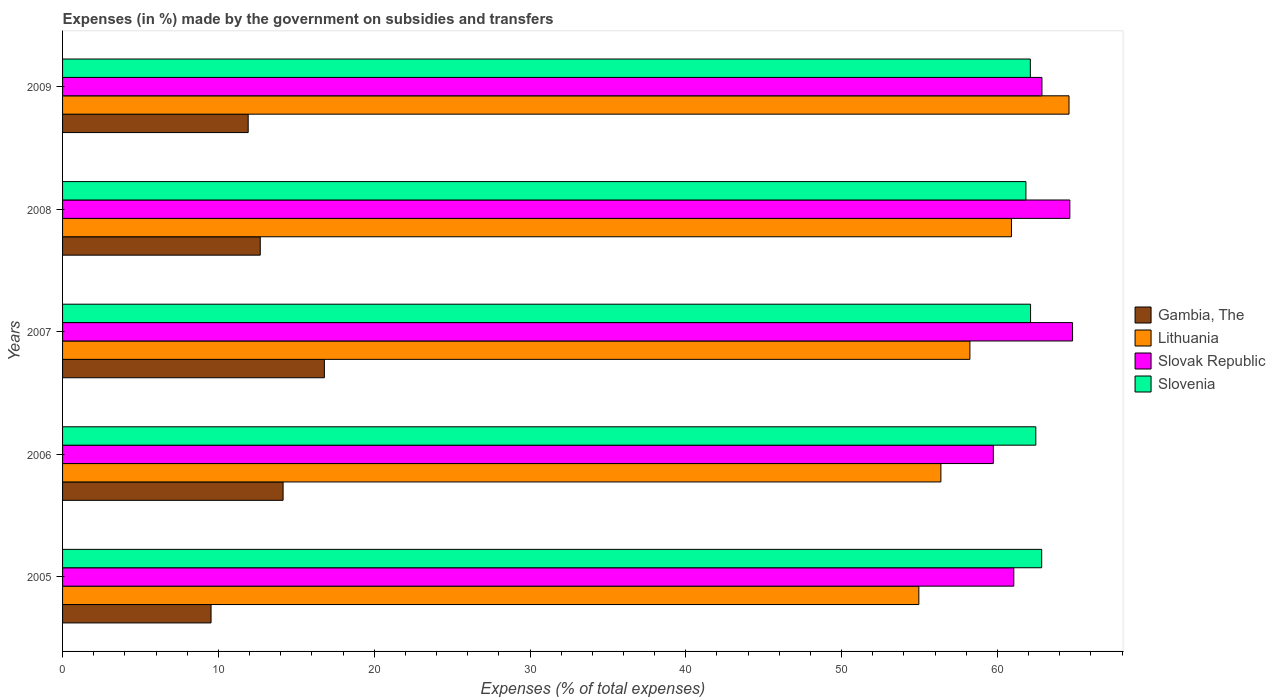How many different coloured bars are there?
Keep it short and to the point. 4. How many groups of bars are there?
Provide a short and direct response. 5. Are the number of bars per tick equal to the number of legend labels?
Offer a terse response. Yes. How many bars are there on the 2nd tick from the top?
Your answer should be compact. 4. What is the label of the 3rd group of bars from the top?
Provide a succinct answer. 2007. What is the percentage of expenses made by the government on subsidies and transfers in Gambia, The in 2009?
Give a very brief answer. 11.91. Across all years, what is the maximum percentage of expenses made by the government on subsidies and transfers in Slovenia?
Your answer should be very brief. 62.84. Across all years, what is the minimum percentage of expenses made by the government on subsidies and transfers in Lithuania?
Your answer should be compact. 54.96. In which year was the percentage of expenses made by the government on subsidies and transfers in Gambia, The maximum?
Keep it short and to the point. 2007. In which year was the percentage of expenses made by the government on subsidies and transfers in Slovak Republic minimum?
Provide a succinct answer. 2006. What is the total percentage of expenses made by the government on subsidies and transfers in Slovenia in the graph?
Keep it short and to the point. 311.37. What is the difference between the percentage of expenses made by the government on subsidies and transfers in Gambia, The in 2007 and that in 2009?
Ensure brevity in your answer.  4.89. What is the difference between the percentage of expenses made by the government on subsidies and transfers in Slovak Republic in 2005 and the percentage of expenses made by the government on subsidies and transfers in Lithuania in 2009?
Keep it short and to the point. -3.54. What is the average percentage of expenses made by the government on subsidies and transfers in Slovak Republic per year?
Keep it short and to the point. 62.62. In the year 2008, what is the difference between the percentage of expenses made by the government on subsidies and transfers in Gambia, The and percentage of expenses made by the government on subsidies and transfers in Slovak Republic?
Offer a terse response. -51.96. In how many years, is the percentage of expenses made by the government on subsidies and transfers in Gambia, The greater than 26 %?
Your response must be concise. 0. What is the ratio of the percentage of expenses made by the government on subsidies and transfers in Lithuania in 2005 to that in 2007?
Provide a short and direct response. 0.94. Is the percentage of expenses made by the government on subsidies and transfers in Slovak Republic in 2007 less than that in 2008?
Provide a succinct answer. No. Is the difference between the percentage of expenses made by the government on subsidies and transfers in Gambia, The in 2005 and 2007 greater than the difference between the percentage of expenses made by the government on subsidies and transfers in Slovak Republic in 2005 and 2007?
Offer a terse response. No. What is the difference between the highest and the second highest percentage of expenses made by the government on subsidies and transfers in Slovenia?
Offer a terse response. 0.38. What is the difference between the highest and the lowest percentage of expenses made by the government on subsidies and transfers in Lithuania?
Make the answer very short. 9.64. What does the 3rd bar from the top in 2007 represents?
Provide a succinct answer. Lithuania. What does the 1st bar from the bottom in 2005 represents?
Ensure brevity in your answer.  Gambia, The. Are all the bars in the graph horizontal?
Provide a succinct answer. Yes. How many years are there in the graph?
Ensure brevity in your answer.  5. Are the values on the major ticks of X-axis written in scientific E-notation?
Your response must be concise. No. Does the graph contain grids?
Give a very brief answer. No. How many legend labels are there?
Make the answer very short. 4. What is the title of the graph?
Ensure brevity in your answer.  Expenses (in %) made by the government on subsidies and transfers. What is the label or title of the X-axis?
Your answer should be very brief. Expenses (% of total expenses). What is the Expenses (% of total expenses) of Gambia, The in 2005?
Your answer should be compact. 9.53. What is the Expenses (% of total expenses) in Lithuania in 2005?
Give a very brief answer. 54.96. What is the Expenses (% of total expenses) of Slovak Republic in 2005?
Your answer should be very brief. 61.05. What is the Expenses (% of total expenses) in Slovenia in 2005?
Your answer should be compact. 62.84. What is the Expenses (% of total expenses) in Gambia, The in 2006?
Offer a very short reply. 14.15. What is the Expenses (% of total expenses) in Lithuania in 2006?
Offer a terse response. 56.37. What is the Expenses (% of total expenses) in Slovak Republic in 2006?
Ensure brevity in your answer.  59.74. What is the Expenses (% of total expenses) in Slovenia in 2006?
Make the answer very short. 62.46. What is the Expenses (% of total expenses) in Gambia, The in 2007?
Offer a terse response. 16.8. What is the Expenses (% of total expenses) in Lithuania in 2007?
Your answer should be very brief. 58.23. What is the Expenses (% of total expenses) of Slovak Republic in 2007?
Your answer should be compact. 64.82. What is the Expenses (% of total expenses) of Slovenia in 2007?
Provide a succinct answer. 62.13. What is the Expenses (% of total expenses) of Gambia, The in 2008?
Your answer should be very brief. 12.69. What is the Expenses (% of total expenses) of Lithuania in 2008?
Ensure brevity in your answer.  60.9. What is the Expenses (% of total expenses) of Slovak Republic in 2008?
Offer a terse response. 64.65. What is the Expenses (% of total expenses) in Slovenia in 2008?
Your answer should be compact. 61.83. What is the Expenses (% of total expenses) in Gambia, The in 2009?
Keep it short and to the point. 11.91. What is the Expenses (% of total expenses) of Lithuania in 2009?
Your answer should be compact. 64.59. What is the Expenses (% of total expenses) in Slovak Republic in 2009?
Offer a terse response. 62.86. What is the Expenses (% of total expenses) of Slovenia in 2009?
Provide a succinct answer. 62.11. Across all years, what is the maximum Expenses (% of total expenses) of Gambia, The?
Your answer should be very brief. 16.8. Across all years, what is the maximum Expenses (% of total expenses) of Lithuania?
Offer a terse response. 64.59. Across all years, what is the maximum Expenses (% of total expenses) of Slovak Republic?
Give a very brief answer. 64.82. Across all years, what is the maximum Expenses (% of total expenses) of Slovenia?
Give a very brief answer. 62.84. Across all years, what is the minimum Expenses (% of total expenses) in Gambia, The?
Give a very brief answer. 9.53. Across all years, what is the minimum Expenses (% of total expenses) in Lithuania?
Provide a succinct answer. 54.96. Across all years, what is the minimum Expenses (% of total expenses) of Slovak Republic?
Offer a very short reply. 59.74. Across all years, what is the minimum Expenses (% of total expenses) in Slovenia?
Offer a terse response. 61.83. What is the total Expenses (% of total expenses) in Gambia, The in the graph?
Your answer should be compact. 65.09. What is the total Expenses (% of total expenses) in Lithuania in the graph?
Your response must be concise. 295.05. What is the total Expenses (% of total expenses) in Slovak Republic in the graph?
Provide a succinct answer. 313.11. What is the total Expenses (% of total expenses) in Slovenia in the graph?
Provide a succinct answer. 311.37. What is the difference between the Expenses (% of total expenses) of Gambia, The in 2005 and that in 2006?
Your answer should be compact. -4.62. What is the difference between the Expenses (% of total expenses) of Lithuania in 2005 and that in 2006?
Keep it short and to the point. -1.42. What is the difference between the Expenses (% of total expenses) of Slovak Republic in 2005 and that in 2006?
Ensure brevity in your answer.  1.31. What is the difference between the Expenses (% of total expenses) in Slovenia in 2005 and that in 2006?
Your response must be concise. 0.38. What is the difference between the Expenses (% of total expenses) of Gambia, The in 2005 and that in 2007?
Your answer should be very brief. -7.27. What is the difference between the Expenses (% of total expenses) of Lithuania in 2005 and that in 2007?
Offer a terse response. -3.28. What is the difference between the Expenses (% of total expenses) in Slovak Republic in 2005 and that in 2007?
Provide a succinct answer. -3.77. What is the difference between the Expenses (% of total expenses) of Slovenia in 2005 and that in 2007?
Provide a short and direct response. 0.71. What is the difference between the Expenses (% of total expenses) in Gambia, The in 2005 and that in 2008?
Your response must be concise. -3.16. What is the difference between the Expenses (% of total expenses) of Lithuania in 2005 and that in 2008?
Provide a short and direct response. -5.94. What is the difference between the Expenses (% of total expenses) in Slovak Republic in 2005 and that in 2008?
Give a very brief answer. -3.6. What is the difference between the Expenses (% of total expenses) in Slovenia in 2005 and that in 2008?
Offer a very short reply. 1.01. What is the difference between the Expenses (% of total expenses) of Gambia, The in 2005 and that in 2009?
Your answer should be very brief. -2.38. What is the difference between the Expenses (% of total expenses) in Lithuania in 2005 and that in 2009?
Offer a terse response. -9.64. What is the difference between the Expenses (% of total expenses) of Slovak Republic in 2005 and that in 2009?
Provide a succinct answer. -1.81. What is the difference between the Expenses (% of total expenses) in Slovenia in 2005 and that in 2009?
Your answer should be compact. 0.73. What is the difference between the Expenses (% of total expenses) of Gambia, The in 2006 and that in 2007?
Offer a very short reply. -2.65. What is the difference between the Expenses (% of total expenses) of Lithuania in 2006 and that in 2007?
Offer a very short reply. -1.86. What is the difference between the Expenses (% of total expenses) in Slovak Republic in 2006 and that in 2007?
Provide a short and direct response. -5.09. What is the difference between the Expenses (% of total expenses) in Slovenia in 2006 and that in 2007?
Offer a very short reply. 0.34. What is the difference between the Expenses (% of total expenses) of Gambia, The in 2006 and that in 2008?
Provide a succinct answer. 1.47. What is the difference between the Expenses (% of total expenses) of Lithuania in 2006 and that in 2008?
Provide a succinct answer. -4.53. What is the difference between the Expenses (% of total expenses) in Slovak Republic in 2006 and that in 2008?
Your response must be concise. -4.91. What is the difference between the Expenses (% of total expenses) in Slovenia in 2006 and that in 2008?
Give a very brief answer. 0.63. What is the difference between the Expenses (% of total expenses) in Gambia, The in 2006 and that in 2009?
Make the answer very short. 2.24. What is the difference between the Expenses (% of total expenses) of Lithuania in 2006 and that in 2009?
Offer a very short reply. -8.22. What is the difference between the Expenses (% of total expenses) of Slovak Republic in 2006 and that in 2009?
Offer a terse response. -3.12. What is the difference between the Expenses (% of total expenses) in Slovenia in 2006 and that in 2009?
Offer a terse response. 0.35. What is the difference between the Expenses (% of total expenses) in Gambia, The in 2007 and that in 2008?
Keep it short and to the point. 4.11. What is the difference between the Expenses (% of total expenses) in Lithuania in 2007 and that in 2008?
Provide a short and direct response. -2.67. What is the difference between the Expenses (% of total expenses) of Slovak Republic in 2007 and that in 2008?
Offer a terse response. 0.17. What is the difference between the Expenses (% of total expenses) in Slovenia in 2007 and that in 2008?
Your answer should be very brief. 0.3. What is the difference between the Expenses (% of total expenses) in Gambia, The in 2007 and that in 2009?
Offer a terse response. 4.89. What is the difference between the Expenses (% of total expenses) in Lithuania in 2007 and that in 2009?
Provide a short and direct response. -6.36. What is the difference between the Expenses (% of total expenses) in Slovak Republic in 2007 and that in 2009?
Your answer should be compact. 1.96. What is the difference between the Expenses (% of total expenses) in Slovenia in 2007 and that in 2009?
Your answer should be compact. 0.01. What is the difference between the Expenses (% of total expenses) in Gambia, The in 2008 and that in 2009?
Provide a succinct answer. 0.77. What is the difference between the Expenses (% of total expenses) of Lithuania in 2008 and that in 2009?
Keep it short and to the point. -3.69. What is the difference between the Expenses (% of total expenses) in Slovak Republic in 2008 and that in 2009?
Your response must be concise. 1.79. What is the difference between the Expenses (% of total expenses) in Slovenia in 2008 and that in 2009?
Offer a terse response. -0.28. What is the difference between the Expenses (% of total expenses) in Gambia, The in 2005 and the Expenses (% of total expenses) in Lithuania in 2006?
Provide a short and direct response. -46.84. What is the difference between the Expenses (% of total expenses) of Gambia, The in 2005 and the Expenses (% of total expenses) of Slovak Republic in 2006?
Your response must be concise. -50.21. What is the difference between the Expenses (% of total expenses) in Gambia, The in 2005 and the Expenses (% of total expenses) in Slovenia in 2006?
Make the answer very short. -52.93. What is the difference between the Expenses (% of total expenses) in Lithuania in 2005 and the Expenses (% of total expenses) in Slovak Republic in 2006?
Keep it short and to the point. -4.78. What is the difference between the Expenses (% of total expenses) of Lithuania in 2005 and the Expenses (% of total expenses) of Slovenia in 2006?
Your answer should be compact. -7.51. What is the difference between the Expenses (% of total expenses) of Slovak Republic in 2005 and the Expenses (% of total expenses) of Slovenia in 2006?
Your answer should be very brief. -1.41. What is the difference between the Expenses (% of total expenses) of Gambia, The in 2005 and the Expenses (% of total expenses) of Lithuania in 2007?
Give a very brief answer. -48.7. What is the difference between the Expenses (% of total expenses) of Gambia, The in 2005 and the Expenses (% of total expenses) of Slovak Republic in 2007?
Offer a very short reply. -55.29. What is the difference between the Expenses (% of total expenses) of Gambia, The in 2005 and the Expenses (% of total expenses) of Slovenia in 2007?
Make the answer very short. -52.6. What is the difference between the Expenses (% of total expenses) in Lithuania in 2005 and the Expenses (% of total expenses) in Slovak Republic in 2007?
Provide a short and direct response. -9.87. What is the difference between the Expenses (% of total expenses) of Lithuania in 2005 and the Expenses (% of total expenses) of Slovenia in 2007?
Your answer should be very brief. -7.17. What is the difference between the Expenses (% of total expenses) in Slovak Republic in 2005 and the Expenses (% of total expenses) in Slovenia in 2007?
Give a very brief answer. -1.08. What is the difference between the Expenses (% of total expenses) in Gambia, The in 2005 and the Expenses (% of total expenses) in Lithuania in 2008?
Your answer should be compact. -51.37. What is the difference between the Expenses (% of total expenses) in Gambia, The in 2005 and the Expenses (% of total expenses) in Slovak Republic in 2008?
Your answer should be compact. -55.12. What is the difference between the Expenses (% of total expenses) of Gambia, The in 2005 and the Expenses (% of total expenses) of Slovenia in 2008?
Your response must be concise. -52.3. What is the difference between the Expenses (% of total expenses) of Lithuania in 2005 and the Expenses (% of total expenses) of Slovak Republic in 2008?
Provide a succinct answer. -9.69. What is the difference between the Expenses (% of total expenses) in Lithuania in 2005 and the Expenses (% of total expenses) in Slovenia in 2008?
Provide a succinct answer. -6.87. What is the difference between the Expenses (% of total expenses) in Slovak Republic in 2005 and the Expenses (% of total expenses) in Slovenia in 2008?
Your answer should be very brief. -0.78. What is the difference between the Expenses (% of total expenses) in Gambia, The in 2005 and the Expenses (% of total expenses) in Lithuania in 2009?
Keep it short and to the point. -55.06. What is the difference between the Expenses (% of total expenses) in Gambia, The in 2005 and the Expenses (% of total expenses) in Slovak Republic in 2009?
Provide a succinct answer. -53.33. What is the difference between the Expenses (% of total expenses) in Gambia, The in 2005 and the Expenses (% of total expenses) in Slovenia in 2009?
Provide a succinct answer. -52.58. What is the difference between the Expenses (% of total expenses) in Lithuania in 2005 and the Expenses (% of total expenses) in Slovak Republic in 2009?
Give a very brief answer. -7.9. What is the difference between the Expenses (% of total expenses) in Lithuania in 2005 and the Expenses (% of total expenses) in Slovenia in 2009?
Provide a succinct answer. -7.16. What is the difference between the Expenses (% of total expenses) of Slovak Republic in 2005 and the Expenses (% of total expenses) of Slovenia in 2009?
Make the answer very short. -1.06. What is the difference between the Expenses (% of total expenses) in Gambia, The in 2006 and the Expenses (% of total expenses) in Lithuania in 2007?
Provide a short and direct response. -44.08. What is the difference between the Expenses (% of total expenses) of Gambia, The in 2006 and the Expenses (% of total expenses) of Slovak Republic in 2007?
Make the answer very short. -50.67. What is the difference between the Expenses (% of total expenses) in Gambia, The in 2006 and the Expenses (% of total expenses) in Slovenia in 2007?
Offer a terse response. -47.97. What is the difference between the Expenses (% of total expenses) of Lithuania in 2006 and the Expenses (% of total expenses) of Slovak Republic in 2007?
Offer a very short reply. -8.45. What is the difference between the Expenses (% of total expenses) of Lithuania in 2006 and the Expenses (% of total expenses) of Slovenia in 2007?
Offer a very short reply. -5.75. What is the difference between the Expenses (% of total expenses) in Slovak Republic in 2006 and the Expenses (% of total expenses) in Slovenia in 2007?
Give a very brief answer. -2.39. What is the difference between the Expenses (% of total expenses) in Gambia, The in 2006 and the Expenses (% of total expenses) in Lithuania in 2008?
Your answer should be very brief. -46.75. What is the difference between the Expenses (% of total expenses) of Gambia, The in 2006 and the Expenses (% of total expenses) of Slovak Republic in 2008?
Give a very brief answer. -50.49. What is the difference between the Expenses (% of total expenses) of Gambia, The in 2006 and the Expenses (% of total expenses) of Slovenia in 2008?
Your answer should be compact. -47.67. What is the difference between the Expenses (% of total expenses) in Lithuania in 2006 and the Expenses (% of total expenses) in Slovak Republic in 2008?
Keep it short and to the point. -8.28. What is the difference between the Expenses (% of total expenses) of Lithuania in 2006 and the Expenses (% of total expenses) of Slovenia in 2008?
Provide a succinct answer. -5.46. What is the difference between the Expenses (% of total expenses) of Slovak Republic in 2006 and the Expenses (% of total expenses) of Slovenia in 2008?
Make the answer very short. -2.09. What is the difference between the Expenses (% of total expenses) in Gambia, The in 2006 and the Expenses (% of total expenses) in Lithuania in 2009?
Make the answer very short. -50.44. What is the difference between the Expenses (% of total expenses) of Gambia, The in 2006 and the Expenses (% of total expenses) of Slovak Republic in 2009?
Offer a terse response. -48.7. What is the difference between the Expenses (% of total expenses) of Gambia, The in 2006 and the Expenses (% of total expenses) of Slovenia in 2009?
Ensure brevity in your answer.  -47.96. What is the difference between the Expenses (% of total expenses) of Lithuania in 2006 and the Expenses (% of total expenses) of Slovak Republic in 2009?
Offer a terse response. -6.49. What is the difference between the Expenses (% of total expenses) of Lithuania in 2006 and the Expenses (% of total expenses) of Slovenia in 2009?
Offer a terse response. -5.74. What is the difference between the Expenses (% of total expenses) in Slovak Republic in 2006 and the Expenses (% of total expenses) in Slovenia in 2009?
Make the answer very short. -2.38. What is the difference between the Expenses (% of total expenses) in Gambia, The in 2007 and the Expenses (% of total expenses) in Lithuania in 2008?
Offer a very short reply. -44.1. What is the difference between the Expenses (% of total expenses) of Gambia, The in 2007 and the Expenses (% of total expenses) of Slovak Republic in 2008?
Your answer should be very brief. -47.84. What is the difference between the Expenses (% of total expenses) in Gambia, The in 2007 and the Expenses (% of total expenses) in Slovenia in 2008?
Give a very brief answer. -45.03. What is the difference between the Expenses (% of total expenses) in Lithuania in 2007 and the Expenses (% of total expenses) in Slovak Republic in 2008?
Your response must be concise. -6.41. What is the difference between the Expenses (% of total expenses) in Lithuania in 2007 and the Expenses (% of total expenses) in Slovenia in 2008?
Keep it short and to the point. -3.6. What is the difference between the Expenses (% of total expenses) in Slovak Republic in 2007 and the Expenses (% of total expenses) in Slovenia in 2008?
Give a very brief answer. 2.99. What is the difference between the Expenses (% of total expenses) in Gambia, The in 2007 and the Expenses (% of total expenses) in Lithuania in 2009?
Keep it short and to the point. -47.79. What is the difference between the Expenses (% of total expenses) of Gambia, The in 2007 and the Expenses (% of total expenses) of Slovak Republic in 2009?
Provide a succinct answer. -46.05. What is the difference between the Expenses (% of total expenses) in Gambia, The in 2007 and the Expenses (% of total expenses) in Slovenia in 2009?
Offer a very short reply. -45.31. What is the difference between the Expenses (% of total expenses) in Lithuania in 2007 and the Expenses (% of total expenses) in Slovak Republic in 2009?
Your answer should be very brief. -4.62. What is the difference between the Expenses (% of total expenses) of Lithuania in 2007 and the Expenses (% of total expenses) of Slovenia in 2009?
Give a very brief answer. -3.88. What is the difference between the Expenses (% of total expenses) in Slovak Republic in 2007 and the Expenses (% of total expenses) in Slovenia in 2009?
Keep it short and to the point. 2.71. What is the difference between the Expenses (% of total expenses) in Gambia, The in 2008 and the Expenses (% of total expenses) in Lithuania in 2009?
Ensure brevity in your answer.  -51.91. What is the difference between the Expenses (% of total expenses) in Gambia, The in 2008 and the Expenses (% of total expenses) in Slovak Republic in 2009?
Offer a terse response. -50.17. What is the difference between the Expenses (% of total expenses) in Gambia, The in 2008 and the Expenses (% of total expenses) in Slovenia in 2009?
Keep it short and to the point. -49.42. What is the difference between the Expenses (% of total expenses) of Lithuania in 2008 and the Expenses (% of total expenses) of Slovak Republic in 2009?
Ensure brevity in your answer.  -1.96. What is the difference between the Expenses (% of total expenses) in Lithuania in 2008 and the Expenses (% of total expenses) in Slovenia in 2009?
Give a very brief answer. -1.21. What is the difference between the Expenses (% of total expenses) in Slovak Republic in 2008 and the Expenses (% of total expenses) in Slovenia in 2009?
Offer a very short reply. 2.53. What is the average Expenses (% of total expenses) of Gambia, The per year?
Your answer should be compact. 13.02. What is the average Expenses (% of total expenses) in Lithuania per year?
Keep it short and to the point. 59.01. What is the average Expenses (% of total expenses) of Slovak Republic per year?
Your answer should be compact. 62.62. What is the average Expenses (% of total expenses) of Slovenia per year?
Provide a succinct answer. 62.27. In the year 2005, what is the difference between the Expenses (% of total expenses) in Gambia, The and Expenses (% of total expenses) in Lithuania?
Your answer should be compact. -45.43. In the year 2005, what is the difference between the Expenses (% of total expenses) of Gambia, The and Expenses (% of total expenses) of Slovak Republic?
Keep it short and to the point. -51.52. In the year 2005, what is the difference between the Expenses (% of total expenses) of Gambia, The and Expenses (% of total expenses) of Slovenia?
Provide a short and direct response. -53.31. In the year 2005, what is the difference between the Expenses (% of total expenses) of Lithuania and Expenses (% of total expenses) of Slovak Republic?
Keep it short and to the point. -6.09. In the year 2005, what is the difference between the Expenses (% of total expenses) of Lithuania and Expenses (% of total expenses) of Slovenia?
Your answer should be very brief. -7.88. In the year 2005, what is the difference between the Expenses (% of total expenses) of Slovak Republic and Expenses (% of total expenses) of Slovenia?
Your answer should be very brief. -1.79. In the year 2006, what is the difference between the Expenses (% of total expenses) in Gambia, The and Expenses (% of total expenses) in Lithuania?
Your response must be concise. -42.22. In the year 2006, what is the difference between the Expenses (% of total expenses) in Gambia, The and Expenses (% of total expenses) in Slovak Republic?
Provide a succinct answer. -45.58. In the year 2006, what is the difference between the Expenses (% of total expenses) in Gambia, The and Expenses (% of total expenses) in Slovenia?
Make the answer very short. -48.31. In the year 2006, what is the difference between the Expenses (% of total expenses) in Lithuania and Expenses (% of total expenses) in Slovak Republic?
Provide a short and direct response. -3.36. In the year 2006, what is the difference between the Expenses (% of total expenses) of Lithuania and Expenses (% of total expenses) of Slovenia?
Offer a terse response. -6.09. In the year 2006, what is the difference between the Expenses (% of total expenses) of Slovak Republic and Expenses (% of total expenses) of Slovenia?
Offer a terse response. -2.73. In the year 2007, what is the difference between the Expenses (% of total expenses) of Gambia, The and Expenses (% of total expenses) of Lithuania?
Your response must be concise. -41.43. In the year 2007, what is the difference between the Expenses (% of total expenses) in Gambia, The and Expenses (% of total expenses) in Slovak Republic?
Your answer should be compact. -48.02. In the year 2007, what is the difference between the Expenses (% of total expenses) in Gambia, The and Expenses (% of total expenses) in Slovenia?
Keep it short and to the point. -45.32. In the year 2007, what is the difference between the Expenses (% of total expenses) in Lithuania and Expenses (% of total expenses) in Slovak Republic?
Provide a short and direct response. -6.59. In the year 2007, what is the difference between the Expenses (% of total expenses) in Lithuania and Expenses (% of total expenses) in Slovenia?
Ensure brevity in your answer.  -3.89. In the year 2007, what is the difference between the Expenses (% of total expenses) in Slovak Republic and Expenses (% of total expenses) in Slovenia?
Keep it short and to the point. 2.7. In the year 2008, what is the difference between the Expenses (% of total expenses) of Gambia, The and Expenses (% of total expenses) of Lithuania?
Provide a succinct answer. -48.21. In the year 2008, what is the difference between the Expenses (% of total expenses) of Gambia, The and Expenses (% of total expenses) of Slovak Republic?
Give a very brief answer. -51.96. In the year 2008, what is the difference between the Expenses (% of total expenses) in Gambia, The and Expenses (% of total expenses) in Slovenia?
Your answer should be very brief. -49.14. In the year 2008, what is the difference between the Expenses (% of total expenses) in Lithuania and Expenses (% of total expenses) in Slovak Republic?
Your response must be concise. -3.75. In the year 2008, what is the difference between the Expenses (% of total expenses) in Lithuania and Expenses (% of total expenses) in Slovenia?
Ensure brevity in your answer.  -0.93. In the year 2008, what is the difference between the Expenses (% of total expenses) of Slovak Republic and Expenses (% of total expenses) of Slovenia?
Your response must be concise. 2.82. In the year 2009, what is the difference between the Expenses (% of total expenses) of Gambia, The and Expenses (% of total expenses) of Lithuania?
Keep it short and to the point. -52.68. In the year 2009, what is the difference between the Expenses (% of total expenses) of Gambia, The and Expenses (% of total expenses) of Slovak Republic?
Your answer should be compact. -50.94. In the year 2009, what is the difference between the Expenses (% of total expenses) in Gambia, The and Expenses (% of total expenses) in Slovenia?
Your response must be concise. -50.2. In the year 2009, what is the difference between the Expenses (% of total expenses) of Lithuania and Expenses (% of total expenses) of Slovak Republic?
Offer a terse response. 1.74. In the year 2009, what is the difference between the Expenses (% of total expenses) of Lithuania and Expenses (% of total expenses) of Slovenia?
Make the answer very short. 2.48. In the year 2009, what is the difference between the Expenses (% of total expenses) in Slovak Republic and Expenses (% of total expenses) in Slovenia?
Your response must be concise. 0.74. What is the ratio of the Expenses (% of total expenses) of Gambia, The in 2005 to that in 2006?
Provide a succinct answer. 0.67. What is the ratio of the Expenses (% of total expenses) in Lithuania in 2005 to that in 2006?
Offer a very short reply. 0.97. What is the ratio of the Expenses (% of total expenses) in Gambia, The in 2005 to that in 2007?
Provide a succinct answer. 0.57. What is the ratio of the Expenses (% of total expenses) of Lithuania in 2005 to that in 2007?
Give a very brief answer. 0.94. What is the ratio of the Expenses (% of total expenses) in Slovak Republic in 2005 to that in 2007?
Provide a short and direct response. 0.94. What is the ratio of the Expenses (% of total expenses) of Slovenia in 2005 to that in 2007?
Give a very brief answer. 1.01. What is the ratio of the Expenses (% of total expenses) of Gambia, The in 2005 to that in 2008?
Provide a succinct answer. 0.75. What is the ratio of the Expenses (% of total expenses) of Lithuania in 2005 to that in 2008?
Ensure brevity in your answer.  0.9. What is the ratio of the Expenses (% of total expenses) in Slovenia in 2005 to that in 2008?
Provide a short and direct response. 1.02. What is the ratio of the Expenses (% of total expenses) in Gambia, The in 2005 to that in 2009?
Offer a terse response. 0.8. What is the ratio of the Expenses (% of total expenses) in Lithuania in 2005 to that in 2009?
Keep it short and to the point. 0.85. What is the ratio of the Expenses (% of total expenses) in Slovak Republic in 2005 to that in 2009?
Offer a very short reply. 0.97. What is the ratio of the Expenses (% of total expenses) in Slovenia in 2005 to that in 2009?
Give a very brief answer. 1.01. What is the ratio of the Expenses (% of total expenses) in Gambia, The in 2006 to that in 2007?
Make the answer very short. 0.84. What is the ratio of the Expenses (% of total expenses) in Slovak Republic in 2006 to that in 2007?
Offer a terse response. 0.92. What is the ratio of the Expenses (% of total expenses) of Slovenia in 2006 to that in 2007?
Offer a very short reply. 1.01. What is the ratio of the Expenses (% of total expenses) in Gambia, The in 2006 to that in 2008?
Make the answer very short. 1.12. What is the ratio of the Expenses (% of total expenses) in Lithuania in 2006 to that in 2008?
Keep it short and to the point. 0.93. What is the ratio of the Expenses (% of total expenses) in Slovak Republic in 2006 to that in 2008?
Offer a very short reply. 0.92. What is the ratio of the Expenses (% of total expenses) of Slovenia in 2006 to that in 2008?
Offer a terse response. 1.01. What is the ratio of the Expenses (% of total expenses) of Gambia, The in 2006 to that in 2009?
Your answer should be compact. 1.19. What is the ratio of the Expenses (% of total expenses) of Lithuania in 2006 to that in 2009?
Your answer should be compact. 0.87. What is the ratio of the Expenses (% of total expenses) in Slovak Republic in 2006 to that in 2009?
Offer a very short reply. 0.95. What is the ratio of the Expenses (% of total expenses) of Slovenia in 2006 to that in 2009?
Make the answer very short. 1.01. What is the ratio of the Expenses (% of total expenses) in Gambia, The in 2007 to that in 2008?
Provide a succinct answer. 1.32. What is the ratio of the Expenses (% of total expenses) of Lithuania in 2007 to that in 2008?
Ensure brevity in your answer.  0.96. What is the ratio of the Expenses (% of total expenses) of Slovenia in 2007 to that in 2008?
Give a very brief answer. 1. What is the ratio of the Expenses (% of total expenses) of Gambia, The in 2007 to that in 2009?
Keep it short and to the point. 1.41. What is the ratio of the Expenses (% of total expenses) of Lithuania in 2007 to that in 2009?
Keep it short and to the point. 0.9. What is the ratio of the Expenses (% of total expenses) in Slovak Republic in 2007 to that in 2009?
Make the answer very short. 1.03. What is the ratio of the Expenses (% of total expenses) in Slovenia in 2007 to that in 2009?
Offer a very short reply. 1. What is the ratio of the Expenses (% of total expenses) of Gambia, The in 2008 to that in 2009?
Your answer should be very brief. 1.06. What is the ratio of the Expenses (% of total expenses) in Lithuania in 2008 to that in 2009?
Keep it short and to the point. 0.94. What is the ratio of the Expenses (% of total expenses) of Slovak Republic in 2008 to that in 2009?
Keep it short and to the point. 1.03. What is the ratio of the Expenses (% of total expenses) in Slovenia in 2008 to that in 2009?
Keep it short and to the point. 1. What is the difference between the highest and the second highest Expenses (% of total expenses) in Gambia, The?
Offer a terse response. 2.65. What is the difference between the highest and the second highest Expenses (% of total expenses) in Lithuania?
Make the answer very short. 3.69. What is the difference between the highest and the second highest Expenses (% of total expenses) in Slovak Republic?
Your answer should be compact. 0.17. What is the difference between the highest and the second highest Expenses (% of total expenses) of Slovenia?
Ensure brevity in your answer.  0.38. What is the difference between the highest and the lowest Expenses (% of total expenses) in Gambia, The?
Provide a short and direct response. 7.27. What is the difference between the highest and the lowest Expenses (% of total expenses) of Lithuania?
Provide a succinct answer. 9.64. What is the difference between the highest and the lowest Expenses (% of total expenses) in Slovak Republic?
Your answer should be compact. 5.09. What is the difference between the highest and the lowest Expenses (% of total expenses) in Slovenia?
Ensure brevity in your answer.  1.01. 